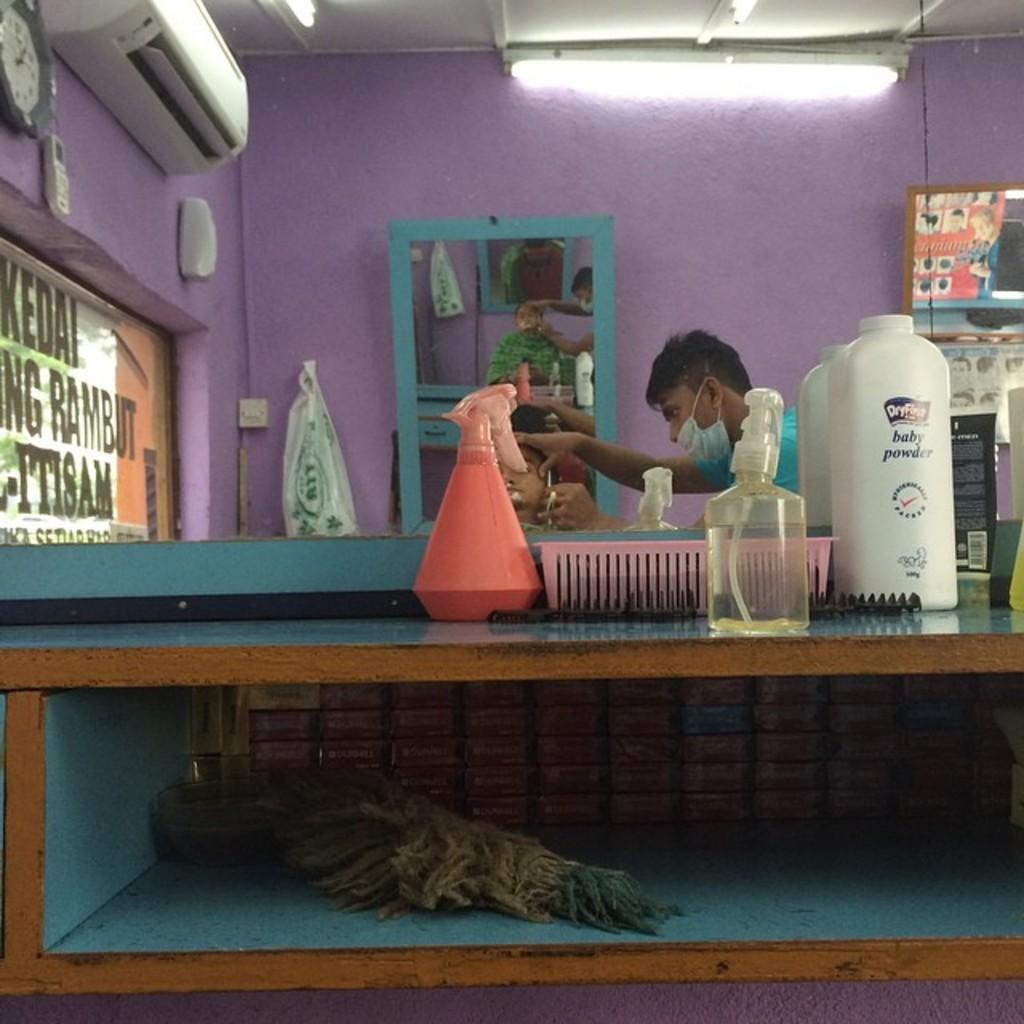<image>
Share a concise interpretation of the image provided. A bottle of DryFirst baby powder on a table in front of a man cutting someone's hair. 